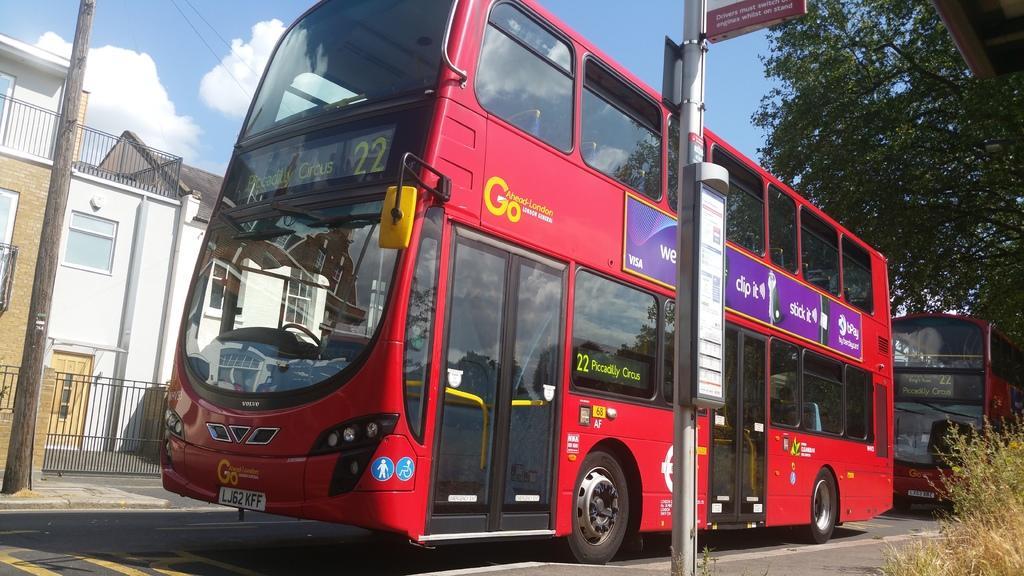How would you summarize this image in a sentence or two? In this image there are two buses on the road, beside the road there is a pole, on the other side if the buses there are houses, behind the buses there are trees. 